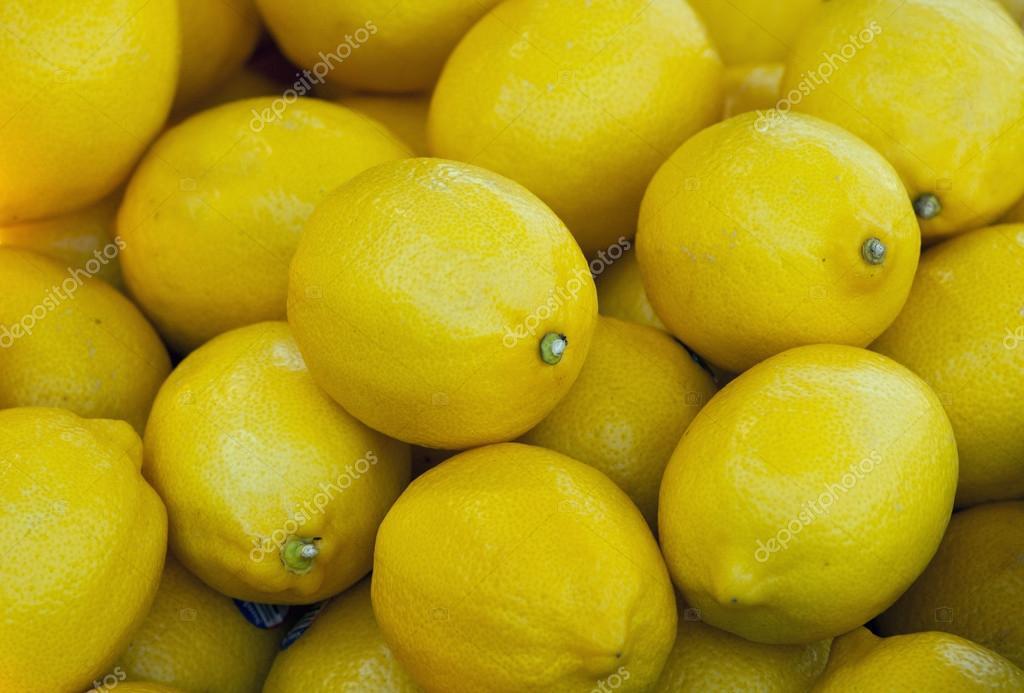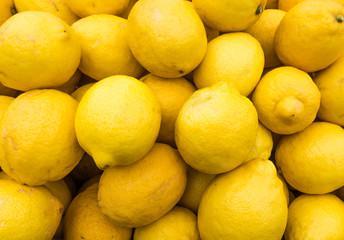The first image is the image on the left, the second image is the image on the right. Given the left and right images, does the statement "In one of the images, a pile of lemons has a dark shadow on the left side." hold true? Answer yes or no. No. 